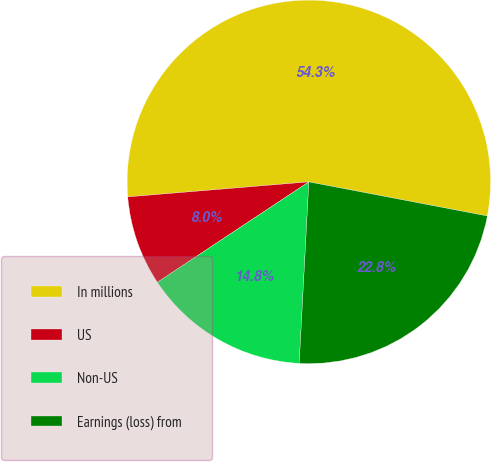Convert chart. <chart><loc_0><loc_0><loc_500><loc_500><pie_chart><fcel>In millions<fcel>US<fcel>Non-US<fcel>Earnings (loss) from<nl><fcel>54.32%<fcel>8.0%<fcel>14.84%<fcel>22.84%<nl></chart> 